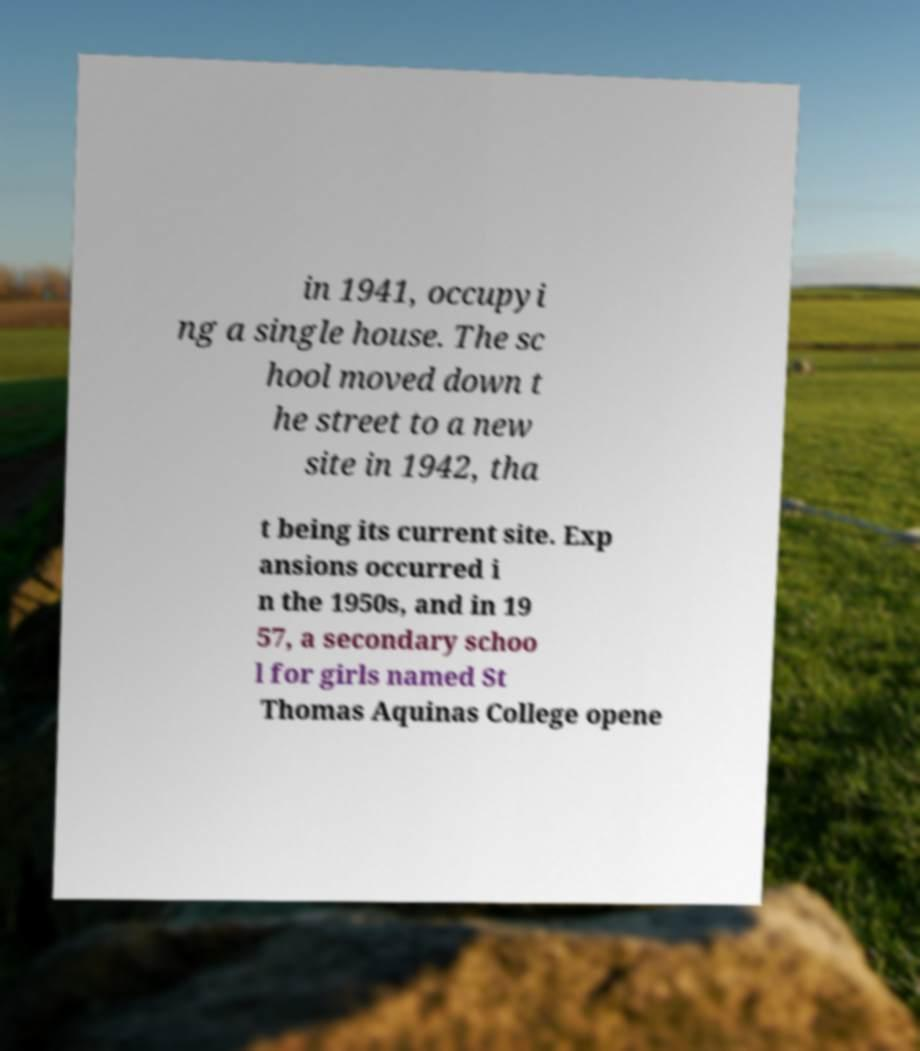Could you assist in decoding the text presented in this image and type it out clearly? in 1941, occupyi ng a single house. The sc hool moved down t he street to a new site in 1942, tha t being its current site. Exp ansions occurred i n the 1950s, and in 19 57, a secondary schoo l for girls named St Thomas Aquinas College opene 